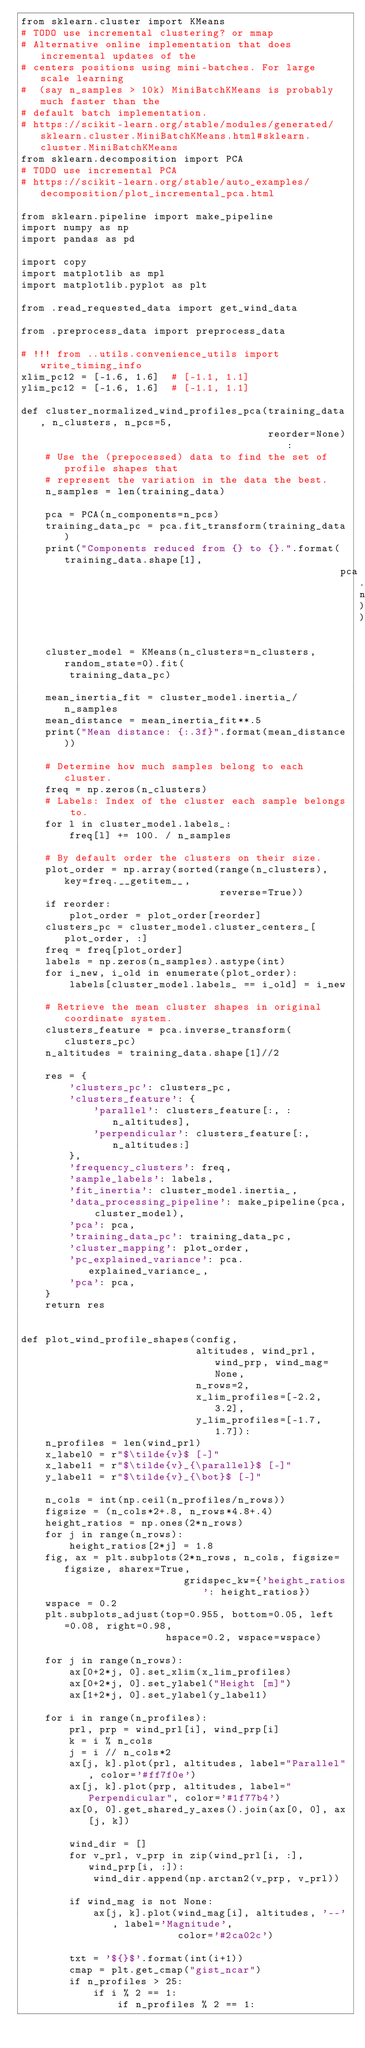Convert code to text. <code><loc_0><loc_0><loc_500><loc_500><_Python_>from sklearn.cluster import KMeans
# TODO use incremental clustering? or mmap
# Alternative online implementation that does incremental updates of the
# centers positions using mini-batches. For large scale learning
#  (say n_samples > 10k) MiniBatchKMeans is probably much faster than the
# default batch implementation.
# https://scikit-learn.org/stable/modules/generated/sklearn.cluster.MiniBatchKMeans.html#sklearn.cluster.MiniBatchKMeans
from sklearn.decomposition import PCA
# TODO use incremental PCA
# https://scikit-learn.org/stable/auto_examples/decomposition/plot_incremental_pca.html

from sklearn.pipeline import make_pipeline
import numpy as np
import pandas as pd

import copy
import matplotlib as mpl
import matplotlib.pyplot as plt

from .read_requested_data import get_wind_data

from .preprocess_data import preprocess_data

# !!! from ..utils.convenience_utils import write_timing_info
xlim_pc12 = [-1.6, 1.6]  # [-1.1, 1.1]
ylim_pc12 = [-1.6, 1.6]  # [-1.1, 1.1]

def cluster_normalized_wind_profiles_pca(training_data, n_clusters, n_pcs=5,
                                         reorder=None):
    # Use the (prepocessed) data to find the set of profile shapes that
    # represent the variation in the data the best.
    n_samples = len(training_data)

    pca = PCA(n_components=n_pcs)
    training_data_pc = pca.fit_transform(training_data)
    print("Components reduced from {} to {}.".format(training_data.shape[1],
                                                     pca.n_components_))

    cluster_model = KMeans(n_clusters=n_clusters, random_state=0).fit(
        training_data_pc)

    mean_inertia_fit = cluster_model.inertia_/n_samples
    mean_distance = mean_inertia_fit**.5
    print("Mean distance: {:.3f}".format(mean_distance))

    # Determine how much samples belong to each cluster.
    freq = np.zeros(n_clusters)
    # Labels: Index of the cluster each sample belongs to.
    for l in cluster_model.labels_:
        freq[l] += 100. / n_samples

    # By default order the clusters on their size.
    plot_order = np.array(sorted(range(n_clusters), key=freq.__getitem__,
                                 reverse=True))
    if reorder:
        plot_order = plot_order[reorder]
    clusters_pc = cluster_model.cluster_centers_[plot_order, :]
    freq = freq[plot_order]
    labels = np.zeros(n_samples).astype(int)
    for i_new, i_old in enumerate(plot_order):
        labels[cluster_model.labels_ == i_old] = i_new

    # Retrieve the mean cluster shapes in original coordinate system.
    clusters_feature = pca.inverse_transform(clusters_pc)
    n_altitudes = training_data.shape[1]//2

    res = {
        'clusters_pc': clusters_pc,
        'clusters_feature': {
            'parallel': clusters_feature[:, :n_altitudes],
            'perpendicular': clusters_feature[:, n_altitudes:]
        },
        'frequency_clusters': freq,
        'sample_labels': labels,
        'fit_inertia': cluster_model.inertia_,
        'data_processing_pipeline': make_pipeline(pca, cluster_model),
        'pca': pca,
        'training_data_pc': training_data_pc,
        'cluster_mapping': plot_order,
        'pc_explained_variance': pca.explained_variance_,
        'pca': pca,
    }
    return res


def plot_wind_profile_shapes(config,
                             altitudes, wind_prl, wind_prp, wind_mag=None,
                             n_rows=2,
                             x_lim_profiles=[-2.2, 3.2],
                             y_lim_profiles=[-1.7, 1.7]):
    n_profiles = len(wind_prl)
    x_label0 = r"$\tilde{v}$ [-]"
    x_label1 = r"$\tilde{v}_{\parallel}$ [-]"
    y_label1 = r"$\tilde{v}_{\bot}$ [-]"

    n_cols = int(np.ceil(n_profiles/n_rows))
    figsize = (n_cols*2+.8, n_rows*4.8+.4)
    height_ratios = np.ones(2*n_rows)
    for j in range(n_rows):
        height_ratios[2*j] = 1.8
    fig, ax = plt.subplots(2*n_rows, n_cols, figsize=figsize, sharex=True,
                           gridspec_kw={'height_ratios': height_ratios})
    wspace = 0.2
    plt.subplots_adjust(top=0.955, bottom=0.05, left=0.08, right=0.98,
                        hspace=0.2, wspace=wspace)

    for j in range(n_rows):
        ax[0+2*j, 0].set_xlim(x_lim_profiles)
        ax[0+2*j, 0].set_ylabel("Height [m]")
        ax[1+2*j, 0].set_ylabel(y_label1)

    for i in range(n_profiles):
        prl, prp = wind_prl[i], wind_prp[i]
        k = i % n_cols
        j = i // n_cols*2
        ax[j, k].plot(prl, altitudes, label="Parallel", color='#ff7f0e')
        ax[j, k].plot(prp, altitudes, label="Perpendicular", color='#1f77b4')
        ax[0, 0].get_shared_y_axes().join(ax[0, 0], ax[j, k])

        wind_dir = []
        for v_prl, v_prp in zip(wind_prl[i, :], wind_prp[i, :]):
            wind_dir.append(np.arctan2(v_prp, v_prl))

        if wind_mag is not None:
            ax[j, k].plot(wind_mag[i], altitudes, '--', label='Magnitude',
                          color='#2ca02c')

        txt = '${}$'.format(int(i+1))
        cmap = plt.get_cmap("gist_ncar")
        if n_profiles > 25:
            if i % 2 == 1:
                if n_profiles % 2 == 1:</code> 